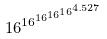Convert formula to latex. <formula><loc_0><loc_0><loc_500><loc_500>1 6 ^ { 1 6 ^ { 1 6 ^ { 1 6 ^ { 1 6 ^ { 4 . 5 2 7 } } } } }</formula> 